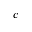<formula> <loc_0><loc_0><loc_500><loc_500>c</formula> 